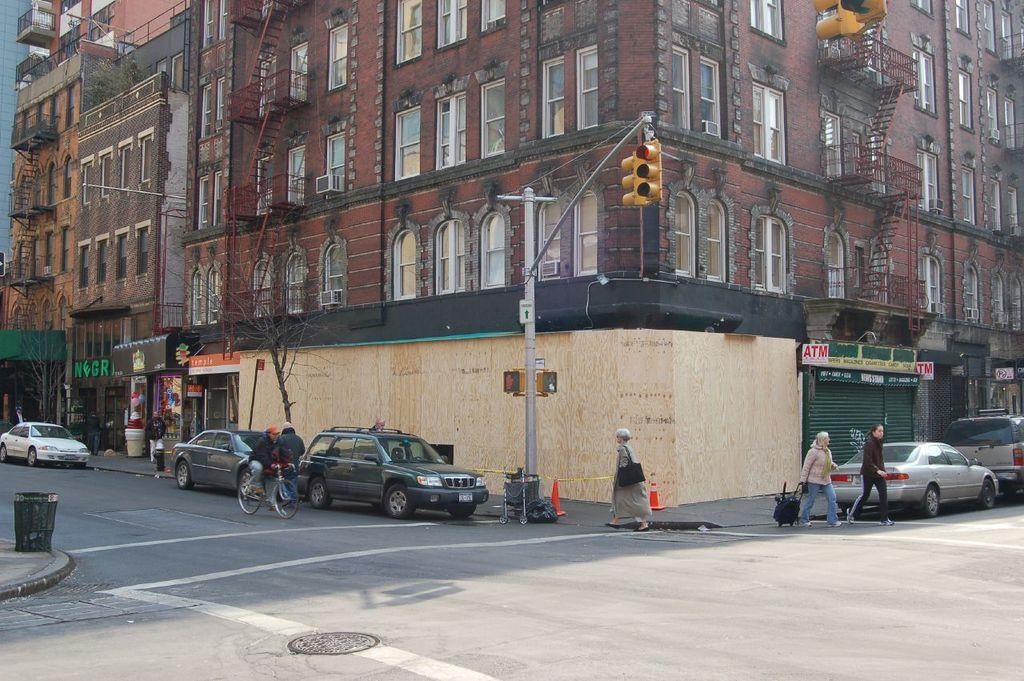How many people are in the image? There are people in the image, but the exact number is not specified. What is one person doing in the image? One person is riding a bicycle in the image. What type of structure is present in the image? There is a building in the image. What type of traffic control device is present in the image? Traffic signals are present in the image. What is attached to the pole in the image? The pole in the image is not described in detail, so it is not clear what is attached to it. What part of the building is visible in the image? Windows are visible in the image, which suggests that the building's exterior is visible. What type of vegetation is present in the image? Trees are present in the image. What type of vehicles are visible on the road in the image? Cars are visible on the road in the image. Where is the crook hiding the bomb in the image? There is no mention of a crook, a bomb, or any criminal activity in the image. The image features people, a bicycle, a building, traffic signals, a pole, windows, trees, and cars on the road. 